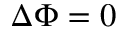<formula> <loc_0><loc_0><loc_500><loc_500>\Delta \Phi = 0</formula> 